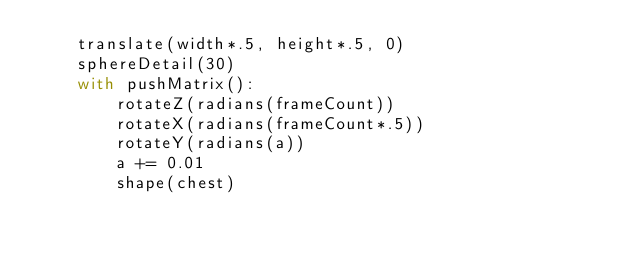Convert code to text. <code><loc_0><loc_0><loc_500><loc_500><_Python_>    translate(width*.5, height*.5, 0)
    sphereDetail(30)
    with pushMatrix():
        rotateZ(radians(frameCount))
        rotateX(radians(frameCount*.5))
        rotateY(radians(a))
        a += 0.01
        shape(chest)</code> 